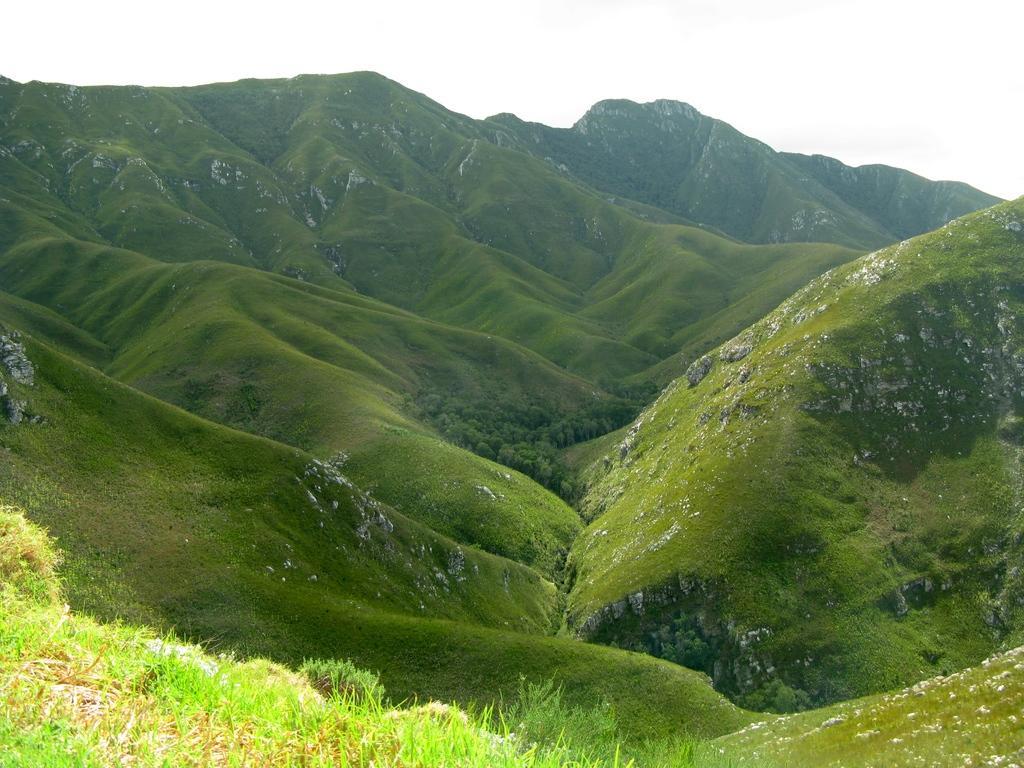Please provide a concise description of this image. This picture might be taken outside of the city. In this image, we can see grass and rocks. On the top, we can see a sky. 